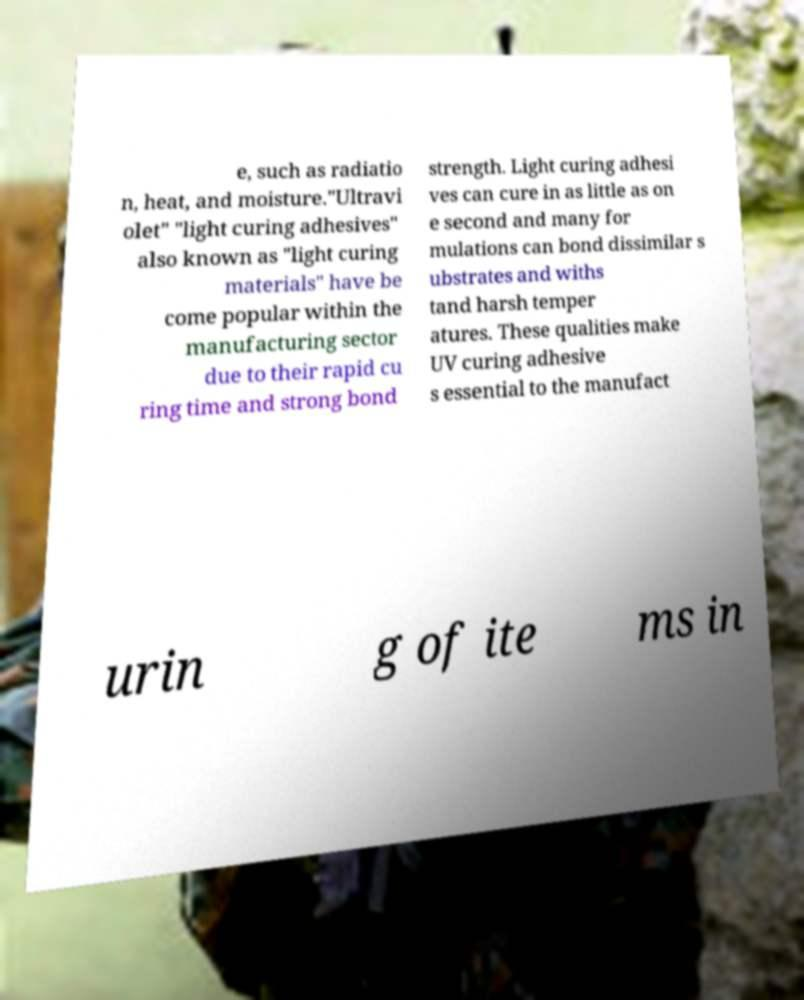For documentation purposes, I need the text within this image transcribed. Could you provide that? e, such as radiatio n, heat, and moisture."Ultravi olet" "light curing adhesives" also known as "light curing materials" have be come popular within the manufacturing sector due to their rapid cu ring time and strong bond strength. Light curing adhesi ves can cure in as little as on e second and many for mulations can bond dissimilar s ubstrates and withs tand harsh temper atures. These qualities make UV curing adhesive s essential to the manufact urin g of ite ms in 